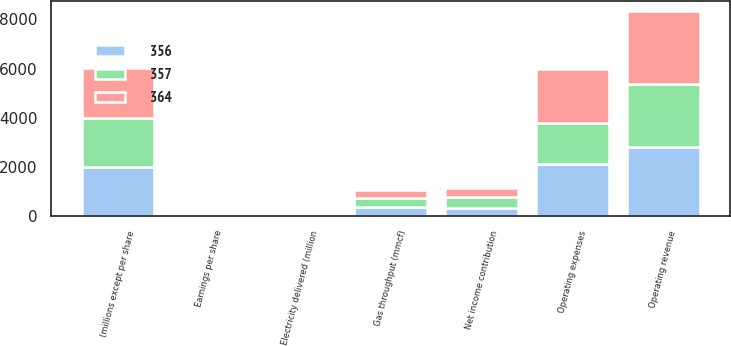Convert chart to OTSL. <chart><loc_0><loc_0><loc_500><loc_500><stacked_bar_chart><ecel><fcel>(millions except per share<fcel>Operating revenue<fcel>Operating expenses<fcel>Net income contribution<fcel>Earnings per share<fcel>Electricity delivered (million<fcel>Gas throughput (mmcf)<nl><fcel>357<fcel>2002<fcel>2552<fcel>1653<fcel>455<fcel>1.61<fcel>75<fcel>364<nl><fcel>364<fcel>2001<fcel>2963<fcel>2202<fcel>366<fcel>1.45<fcel>72<fcel>357<nl><fcel>356<fcel>2000<fcel>2826<fcel>2123<fcel>339<fcel>1.43<fcel>74<fcel>356<nl></chart> 